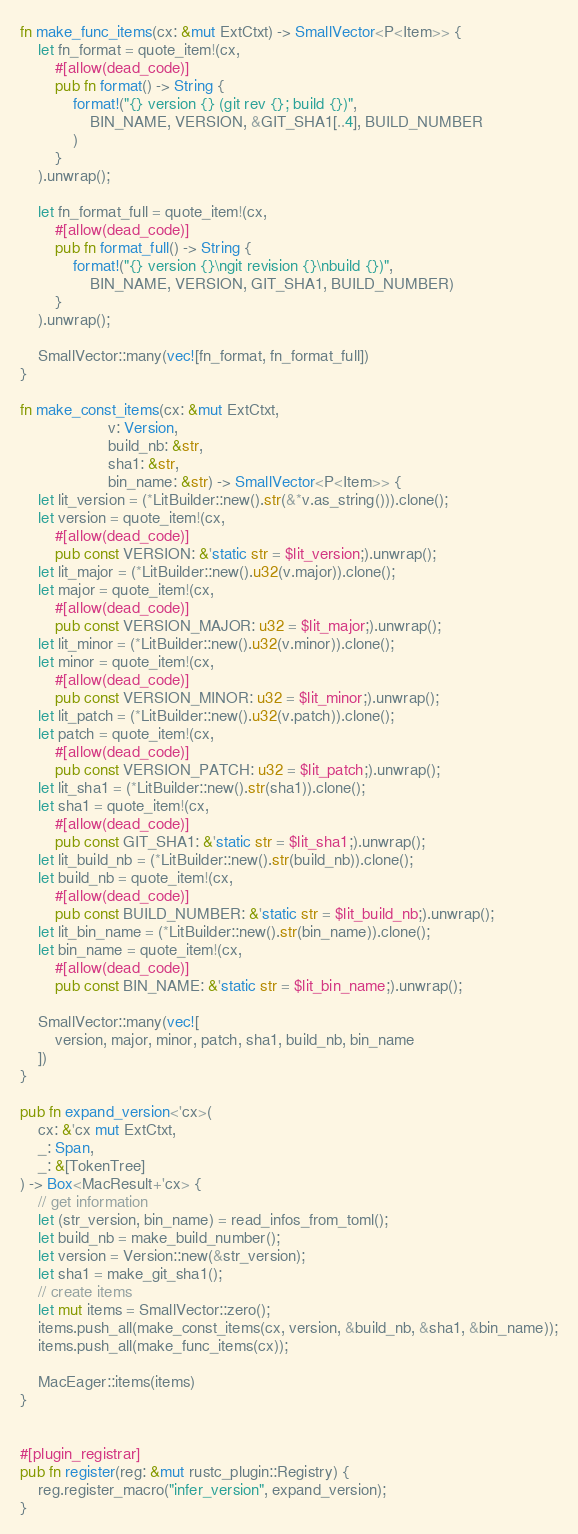Convert code to text. <code><loc_0><loc_0><loc_500><loc_500><_Rust_>fn make_func_items(cx: &mut ExtCtxt) -> SmallVector<P<Item>> {
    let fn_format = quote_item!(cx,
        #[allow(dead_code)]
        pub fn format() -> String {
            format!("{} version {} (git rev {}; build {})",
                BIN_NAME, VERSION, &GIT_SHA1[..4], BUILD_NUMBER
            )
        }
    ).unwrap();

    let fn_format_full = quote_item!(cx,
        #[allow(dead_code)]
        pub fn format_full() -> String {
            format!("{} version {}\ngit revision {}\nbuild {})",
                BIN_NAME, VERSION, GIT_SHA1, BUILD_NUMBER)
        }
    ).unwrap();

    SmallVector::many(vec![fn_format, fn_format_full])
}

fn make_const_items(cx: &mut ExtCtxt,
                    v: Version,
                    build_nb: &str,
                    sha1: &str,
                    bin_name: &str) -> SmallVector<P<Item>> {
    let lit_version = (*LitBuilder::new().str(&*v.as_string())).clone();
    let version = quote_item!(cx,
        #[allow(dead_code)]
        pub const VERSION: &'static str = $lit_version;).unwrap();
    let lit_major = (*LitBuilder::new().u32(v.major)).clone();
    let major = quote_item!(cx,
        #[allow(dead_code)]
        pub const VERSION_MAJOR: u32 = $lit_major;).unwrap();
    let lit_minor = (*LitBuilder::new().u32(v.minor)).clone();
    let minor = quote_item!(cx,
        #[allow(dead_code)]
        pub const VERSION_MINOR: u32 = $lit_minor;).unwrap();
    let lit_patch = (*LitBuilder::new().u32(v.patch)).clone();
    let patch = quote_item!(cx,
        #[allow(dead_code)]
        pub const VERSION_PATCH: u32 = $lit_patch;).unwrap();
    let lit_sha1 = (*LitBuilder::new().str(sha1)).clone();
    let sha1 = quote_item!(cx,
        #[allow(dead_code)]
        pub const GIT_SHA1: &'static str = $lit_sha1;).unwrap();
    let lit_build_nb = (*LitBuilder::new().str(build_nb)).clone();
    let build_nb = quote_item!(cx,
        #[allow(dead_code)]
        pub const BUILD_NUMBER: &'static str = $lit_build_nb;).unwrap();
    let lit_bin_name = (*LitBuilder::new().str(bin_name)).clone();
    let bin_name = quote_item!(cx,
        #[allow(dead_code)]
        pub const BIN_NAME: &'static str = $lit_bin_name;).unwrap();

    SmallVector::many(vec![
        version, major, minor, patch, sha1, build_nb, bin_name
    ])
}

pub fn expand_version<'cx>(
    cx: &'cx mut ExtCtxt,
    _: Span,
    _: &[TokenTree]
) -> Box<MacResult+'cx> {
    // get information
    let (str_version, bin_name) = read_infos_from_toml();
    let build_nb = make_build_number();
    let version = Version::new(&str_version);
    let sha1 = make_git_sha1();
    // create items
    let mut items = SmallVector::zero();
    items.push_all(make_const_items(cx, version, &build_nb, &sha1, &bin_name));
    items.push_all(make_func_items(cx));

    MacEager::items(items)
}


#[plugin_registrar]
pub fn register(reg: &mut rustc_plugin::Registry) {
    reg.register_macro("infer_version", expand_version);
}
</code> 